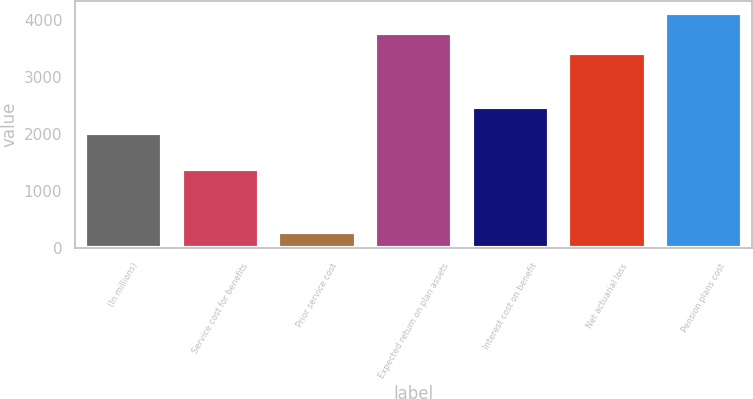Convert chart. <chart><loc_0><loc_0><loc_500><loc_500><bar_chart><fcel>(In millions)<fcel>Service cost for benefits<fcel>Prior service cost<fcel>Expected return on plan assets<fcel>Interest cost on benefit<fcel>Net actuarial loss<fcel>Pension plans cost<nl><fcel>2012<fcel>1387<fcel>279<fcel>3772.9<fcel>2479<fcel>3421<fcel>4124.8<nl></chart> 